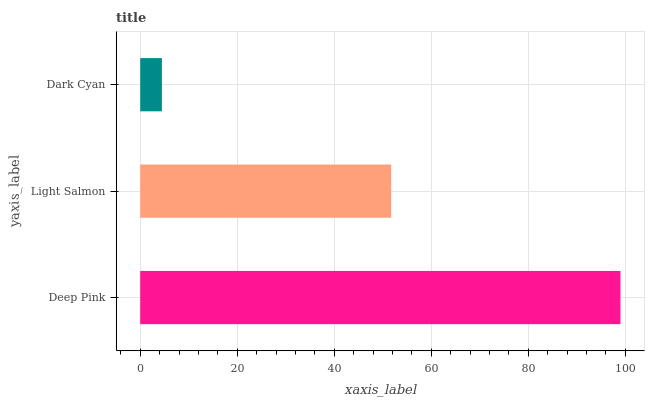Is Dark Cyan the minimum?
Answer yes or no. Yes. Is Deep Pink the maximum?
Answer yes or no. Yes. Is Light Salmon the minimum?
Answer yes or no. No. Is Light Salmon the maximum?
Answer yes or no. No. Is Deep Pink greater than Light Salmon?
Answer yes or no. Yes. Is Light Salmon less than Deep Pink?
Answer yes or no. Yes. Is Light Salmon greater than Deep Pink?
Answer yes or no. No. Is Deep Pink less than Light Salmon?
Answer yes or no. No. Is Light Salmon the high median?
Answer yes or no. Yes. Is Light Salmon the low median?
Answer yes or no. Yes. Is Dark Cyan the high median?
Answer yes or no. No. Is Deep Pink the low median?
Answer yes or no. No. 